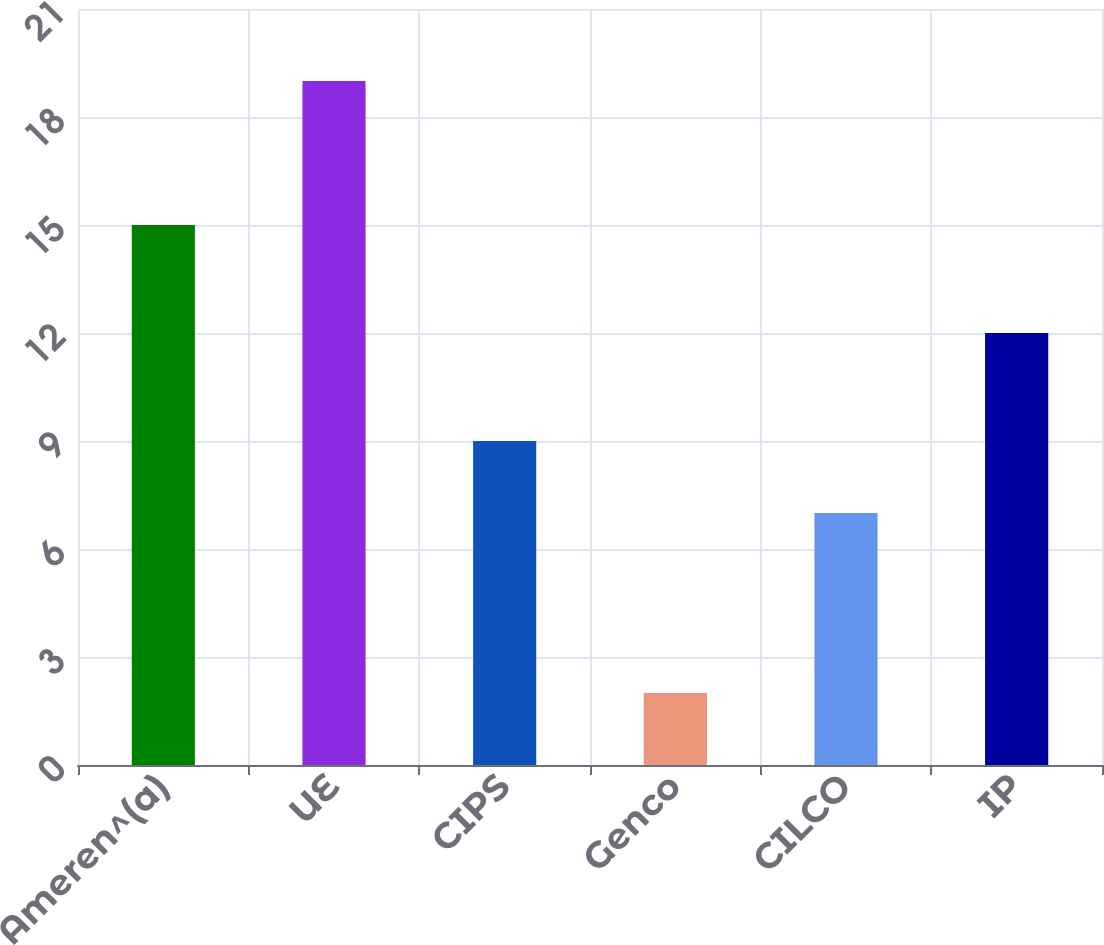Convert chart. <chart><loc_0><loc_0><loc_500><loc_500><bar_chart><fcel>Ameren^(a)<fcel>UE<fcel>CIPS<fcel>Genco<fcel>CILCO<fcel>IP<nl><fcel>15<fcel>19<fcel>9<fcel>2<fcel>7<fcel>12<nl></chart> 